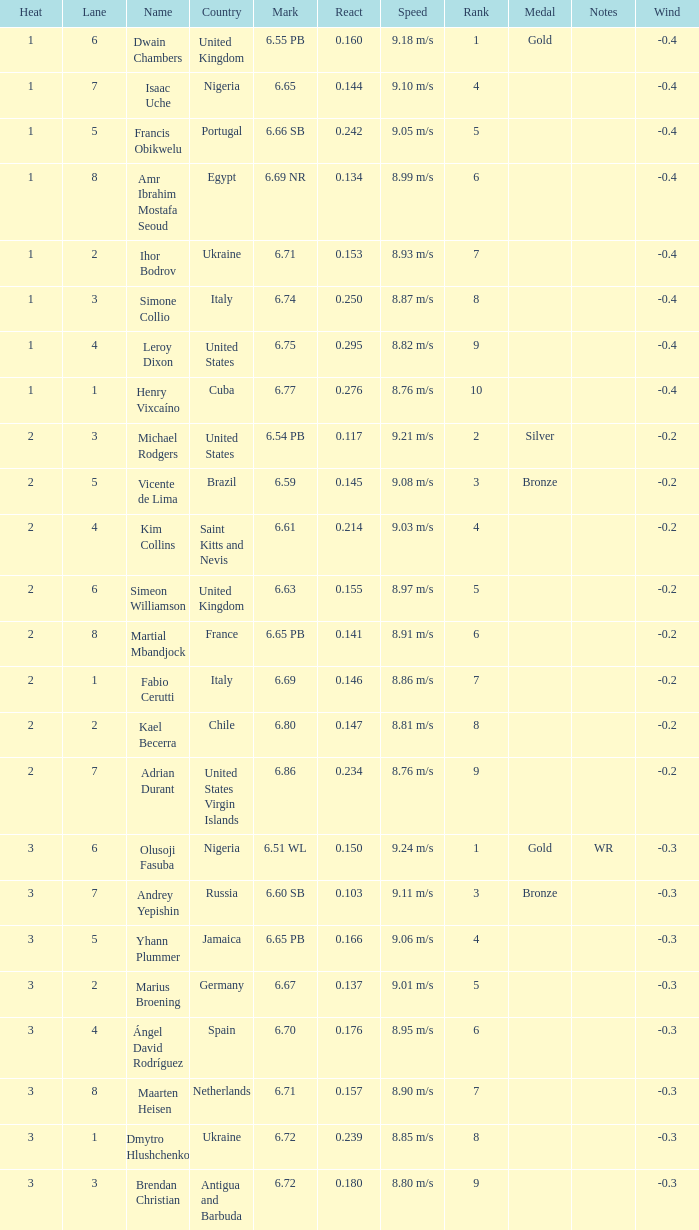Parse the table in full. {'header': ['Heat', 'Lane', 'Name', 'Country', 'Mark', 'React', 'Speed', 'Rank', 'Medal', 'Notes', 'Wind'], 'rows': [['1', '6', 'Dwain Chambers', 'United Kingdom', '6.55 PB', '0.160', '9.18 m/s', '1', 'Gold', '', '-0.4'], ['1', '7', 'Isaac Uche', 'Nigeria', '6.65', '0.144', '9.10 m/s', '4', '', '', '-0.4'], ['1', '5', 'Francis Obikwelu', 'Portugal', '6.66 SB', '0.242', '9.05 m/s', '5', '', '', '-0.4'], ['1', '8', 'Amr Ibrahim Mostafa Seoud', 'Egypt', '6.69 NR', '0.134', '8.99 m/s', '6', '', '', '-0.4'], ['1', '2', 'Ihor Bodrov', 'Ukraine', '6.71', '0.153', '8.93 m/s', '7', '', '', '-0.4'], ['1', '3', 'Simone Collio', 'Italy', '6.74', '0.250', '8.87 m/s', '8', '', '', '-0.4'], ['1', '4', 'Leroy Dixon', 'United States', '6.75', '0.295', '8.82 m/s', '9', '', '', '-0.4'], ['1', '1', 'Henry Vixcaíno', 'Cuba', '6.77', '0.276', '8.76 m/s', '10', '', '', '-0.4'], ['2', '3', 'Michael Rodgers', 'United States', '6.54 PB', '0.117', '9.21 m/s', '2', 'Silver', '', '-0.2'], ['2', '5', 'Vicente de Lima', 'Brazil', '6.59', '0.145', '9.08 m/s', '3', 'Bronze', '', '-0.2'], ['2', '4', 'Kim Collins', 'Saint Kitts and Nevis', '6.61', '0.214', '9.03 m/s', '4', '', '', '-0.2'], ['2', '6', 'Simeon Williamson', 'United Kingdom', '6.63', '0.155', '8.97 m/s', '5', '', '', '-0.2'], ['2', '8', 'Martial Mbandjock', 'France', '6.65 PB', '0.141', '8.91 m/s', '6', '', '', '-0.2'], ['2', '1', 'Fabio Cerutti', 'Italy', '6.69', '0.146', '8.86 m/s', '7', '', '', '-0.2'], ['2', '2', 'Kael Becerra', 'Chile', '6.80', '0.147', '8.81 m/s', '8', '', '', '-0.2'], ['2', '7', 'Adrian Durant', 'United States Virgin Islands', '6.86', '0.234', '8.76 m/s', '9', '', '', '-0.2'], ['3', '6', 'Olusoji Fasuba', 'Nigeria', '6.51 WL', '0.150', '9.24 m/s', '1', 'Gold', 'WR', '-0.3'], ['3', '7', 'Andrey Yepishin', 'Russia', '6.60 SB', '0.103', '9.11 m/s', '3', 'Bronze', '', '-0.3'], ['3', '5', 'Yhann Plummer', 'Jamaica', '6.65 PB', '0.166', '9.06 m/s', '4', '', '', '-0.3'], ['3', '2', 'Marius Broening', 'Germany', '6.67', '0.137', '9.01 m/s', '5', '', '', '-0.3'], ['3', '4', 'Ángel David Rodríguez', 'Spain', '6.70', '0.176', '8.95 m/s', '6', '', '', '-0.3'], ['3', '8', 'Maarten Heisen', 'Netherlands', '6.71', '0.157', '8.90 m/s', '7', '', '', '-0.3'], ['3', '1', 'Dmytro Hlushchenko', 'Ukraine', '6.72', '0.239', '8.85 m/s', '8', '', '', '-0.3'], ['3', '3', 'Brendan Christian', 'Antigua and Barbuda', '6.72', '0.180', '8.80 m/s', '9', '', '', '-0.3']]} What is temperature, when mark is 2.0. 